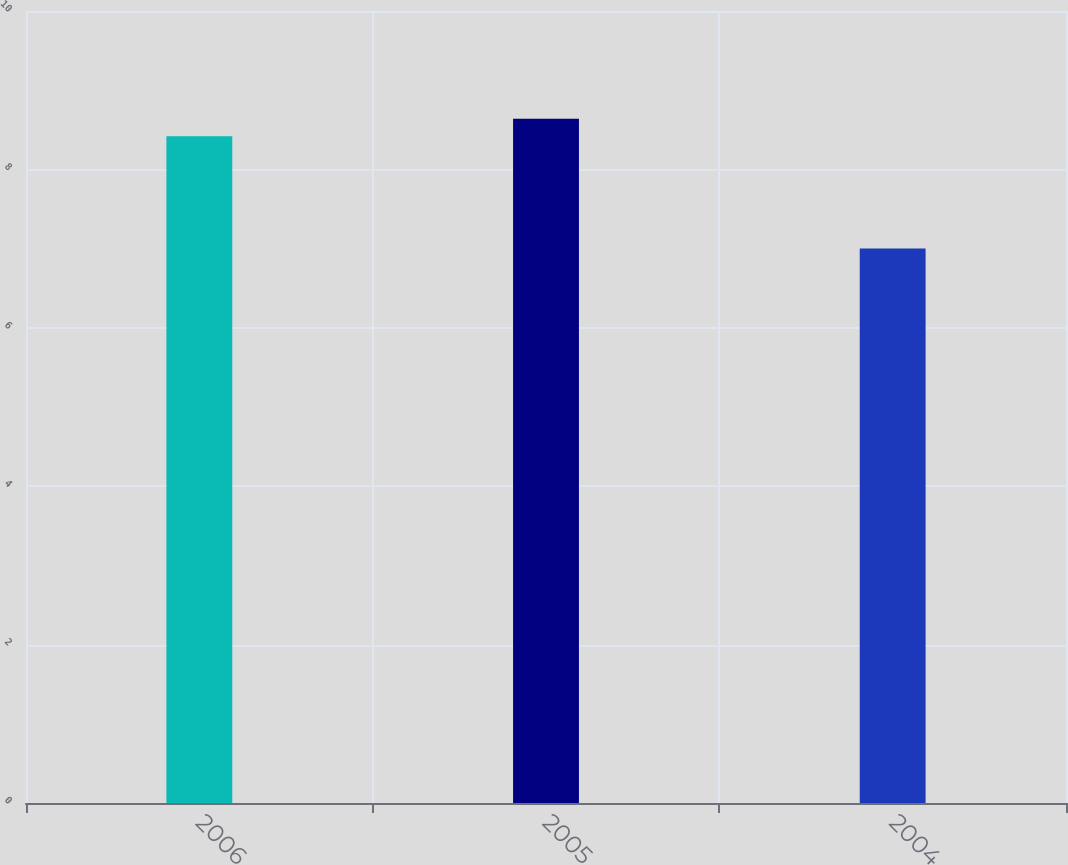Convert chart. <chart><loc_0><loc_0><loc_500><loc_500><bar_chart><fcel>2006<fcel>2005<fcel>2004<nl><fcel>8.42<fcel>8.64<fcel>7<nl></chart> 